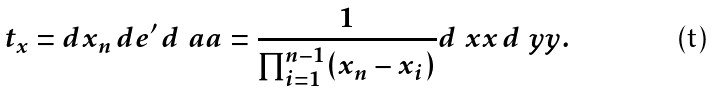Convert formula to latex. <formula><loc_0><loc_0><loc_500><loc_500>t _ { x } = d x _ { n } \, d { e } ^ { \prime } \, d \ a a = \frac { 1 } { \prod _ { i = 1 } ^ { n - 1 } ( x _ { n } - x _ { i } ) } d \ x x \, d \ y y .</formula> 